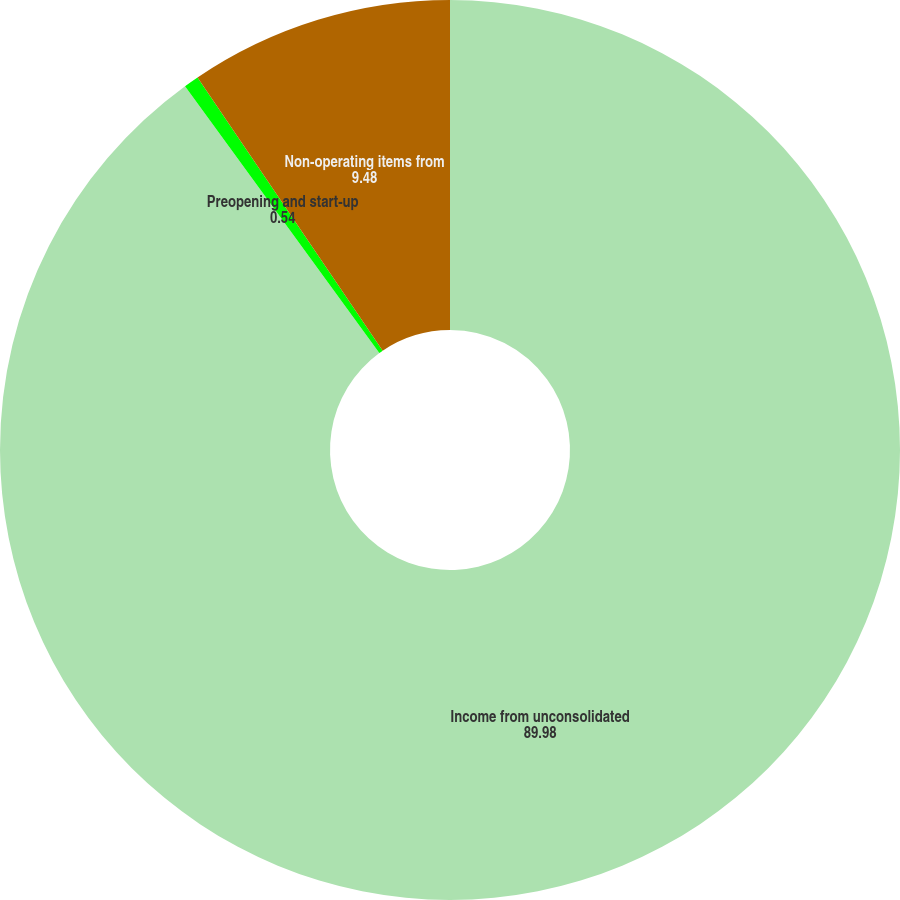<chart> <loc_0><loc_0><loc_500><loc_500><pie_chart><fcel>Income from unconsolidated<fcel>Preopening and start-up<fcel>Non-operating items from<nl><fcel>89.98%<fcel>0.54%<fcel>9.48%<nl></chart> 